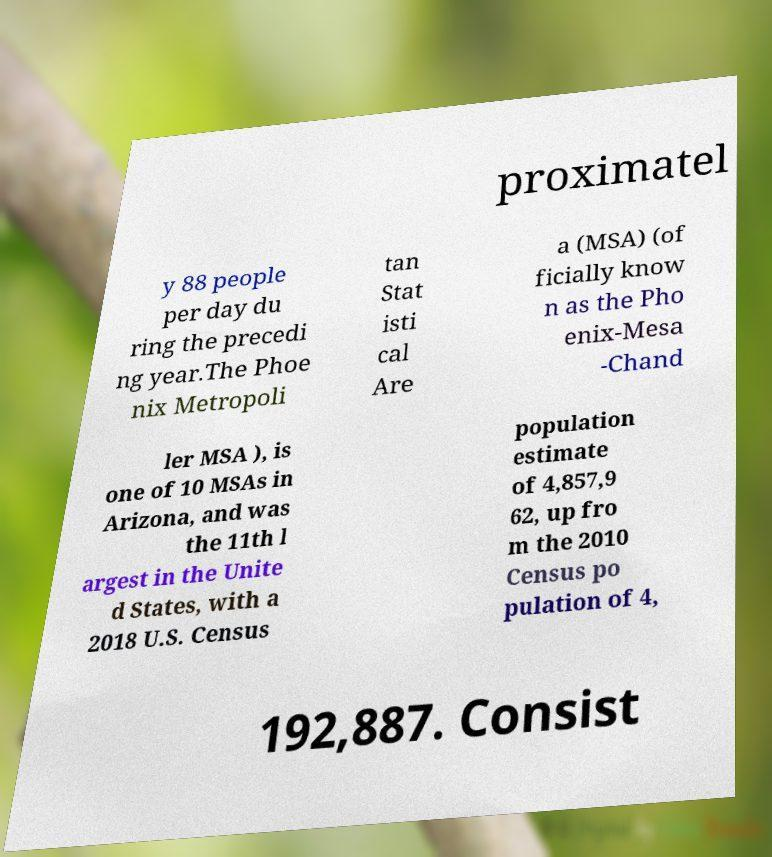Please identify and transcribe the text found in this image. proximatel y 88 people per day du ring the precedi ng year.The Phoe nix Metropoli tan Stat isti cal Are a (MSA) (of ficially know n as the Pho enix-Mesa -Chand ler MSA ), is one of 10 MSAs in Arizona, and was the 11th l argest in the Unite d States, with a 2018 U.S. Census population estimate of 4,857,9 62, up fro m the 2010 Census po pulation of 4, 192,887. Consist 